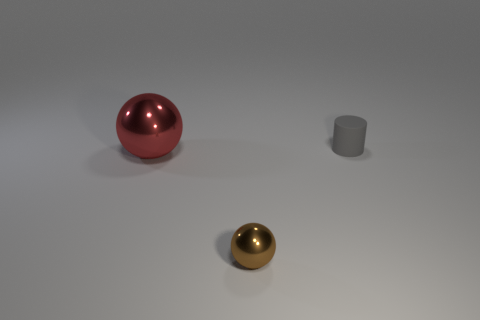Is there any other thing that is the same shape as the small matte object?
Keep it short and to the point. No. There is another shiny object that is the same shape as the large thing; what color is it?
Offer a very short reply. Brown. What is the material of the small object to the left of the tiny gray cylinder?
Make the answer very short. Metal. What is the color of the rubber cylinder?
Make the answer very short. Gray. There is a thing that is to the right of the brown thing; is it the same size as the tiny metal object?
Your answer should be very brief. Yes. What is the object in front of the ball behind the tiny object in front of the cylinder made of?
Your response must be concise. Metal. There is a small object that is left of the tiny cylinder; does it have the same color as the thing behind the red ball?
Offer a very short reply. No. What is the material of the small thing behind the small thing that is in front of the matte cylinder?
Your answer should be very brief. Rubber. There is a thing that is the same size as the brown sphere; what color is it?
Offer a very short reply. Gray. There is a brown shiny object; is it the same shape as the metal thing that is behind the small brown metal sphere?
Your response must be concise. Yes. 